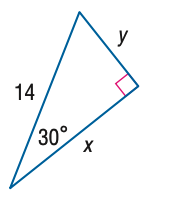Answer the mathemtical geometry problem and directly provide the correct option letter.
Question: Find y.
Choices: A: 7 B: 7 \sqrt { 2 } C: 7 \sqrt { 3 } D: 14 A 